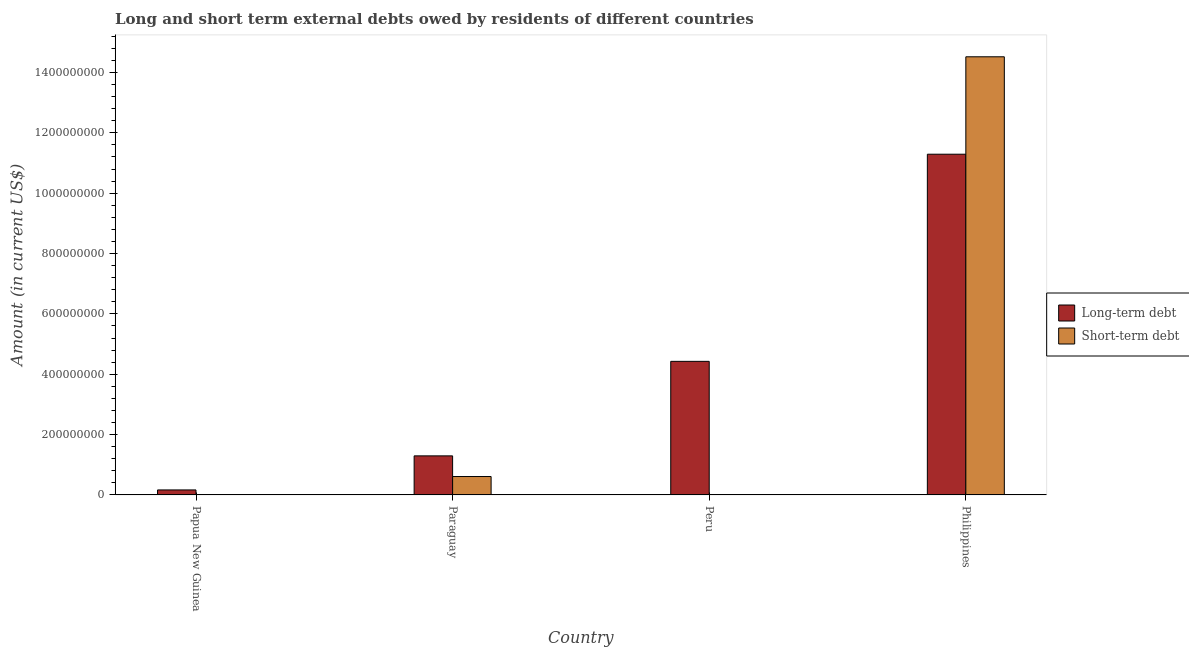Are the number of bars per tick equal to the number of legend labels?
Your answer should be compact. No. Are the number of bars on each tick of the X-axis equal?
Offer a very short reply. No. How many bars are there on the 4th tick from the left?
Your answer should be compact. 2. What is the label of the 3rd group of bars from the left?
Make the answer very short. Peru. What is the short-term debts owed by residents in Peru?
Give a very brief answer. 0. Across all countries, what is the maximum short-term debts owed by residents?
Offer a very short reply. 1.45e+09. Across all countries, what is the minimum long-term debts owed by residents?
Give a very brief answer. 1.66e+07. What is the total short-term debts owed by residents in the graph?
Provide a succinct answer. 1.51e+09. What is the difference between the long-term debts owed by residents in Papua New Guinea and that in Peru?
Your response must be concise. -4.26e+08. What is the difference between the long-term debts owed by residents in Peru and the short-term debts owed by residents in Papua New Guinea?
Provide a succinct answer. 4.43e+08. What is the average short-term debts owed by residents per country?
Provide a short and direct response. 3.78e+08. What is the difference between the long-term debts owed by residents and short-term debts owed by residents in Paraguay?
Your answer should be compact. 6.85e+07. In how many countries, is the long-term debts owed by residents greater than 40000000 US$?
Offer a very short reply. 3. What is the ratio of the long-term debts owed by residents in Peru to that in Philippines?
Offer a very short reply. 0.39. What is the difference between the highest and the second highest long-term debts owed by residents?
Your answer should be very brief. 6.86e+08. What is the difference between the highest and the lowest long-term debts owed by residents?
Make the answer very short. 1.11e+09. In how many countries, is the short-term debts owed by residents greater than the average short-term debts owed by residents taken over all countries?
Your answer should be very brief. 1. How many bars are there?
Ensure brevity in your answer.  6. Are all the bars in the graph horizontal?
Offer a very short reply. No. How many countries are there in the graph?
Provide a short and direct response. 4. Where does the legend appear in the graph?
Your answer should be compact. Center right. How are the legend labels stacked?
Your answer should be very brief. Vertical. What is the title of the graph?
Make the answer very short. Long and short term external debts owed by residents of different countries. What is the Amount (in current US$) of Long-term debt in Papua New Guinea?
Your answer should be compact. 1.66e+07. What is the Amount (in current US$) in Short-term debt in Papua New Guinea?
Provide a short and direct response. 0. What is the Amount (in current US$) of Long-term debt in Paraguay?
Give a very brief answer. 1.29e+08. What is the Amount (in current US$) in Short-term debt in Paraguay?
Keep it short and to the point. 6.10e+07. What is the Amount (in current US$) of Long-term debt in Peru?
Provide a succinct answer. 4.43e+08. What is the Amount (in current US$) of Short-term debt in Peru?
Your answer should be compact. 0. What is the Amount (in current US$) of Long-term debt in Philippines?
Offer a very short reply. 1.13e+09. What is the Amount (in current US$) of Short-term debt in Philippines?
Make the answer very short. 1.45e+09. Across all countries, what is the maximum Amount (in current US$) in Long-term debt?
Your answer should be very brief. 1.13e+09. Across all countries, what is the maximum Amount (in current US$) of Short-term debt?
Your response must be concise. 1.45e+09. Across all countries, what is the minimum Amount (in current US$) in Long-term debt?
Make the answer very short. 1.66e+07. What is the total Amount (in current US$) in Long-term debt in the graph?
Your answer should be very brief. 1.72e+09. What is the total Amount (in current US$) of Short-term debt in the graph?
Give a very brief answer. 1.51e+09. What is the difference between the Amount (in current US$) in Long-term debt in Papua New Guinea and that in Paraguay?
Keep it short and to the point. -1.13e+08. What is the difference between the Amount (in current US$) of Long-term debt in Papua New Guinea and that in Peru?
Keep it short and to the point. -4.26e+08. What is the difference between the Amount (in current US$) in Long-term debt in Papua New Guinea and that in Philippines?
Give a very brief answer. -1.11e+09. What is the difference between the Amount (in current US$) of Long-term debt in Paraguay and that in Peru?
Ensure brevity in your answer.  -3.13e+08. What is the difference between the Amount (in current US$) of Long-term debt in Paraguay and that in Philippines?
Give a very brief answer. -1.00e+09. What is the difference between the Amount (in current US$) in Short-term debt in Paraguay and that in Philippines?
Provide a succinct answer. -1.39e+09. What is the difference between the Amount (in current US$) of Long-term debt in Peru and that in Philippines?
Your response must be concise. -6.86e+08. What is the difference between the Amount (in current US$) of Long-term debt in Papua New Guinea and the Amount (in current US$) of Short-term debt in Paraguay?
Offer a terse response. -4.44e+07. What is the difference between the Amount (in current US$) of Long-term debt in Papua New Guinea and the Amount (in current US$) of Short-term debt in Philippines?
Provide a short and direct response. -1.44e+09. What is the difference between the Amount (in current US$) in Long-term debt in Paraguay and the Amount (in current US$) in Short-term debt in Philippines?
Your response must be concise. -1.32e+09. What is the difference between the Amount (in current US$) of Long-term debt in Peru and the Amount (in current US$) of Short-term debt in Philippines?
Offer a terse response. -1.01e+09. What is the average Amount (in current US$) in Long-term debt per country?
Offer a terse response. 4.29e+08. What is the average Amount (in current US$) of Short-term debt per country?
Your response must be concise. 3.78e+08. What is the difference between the Amount (in current US$) in Long-term debt and Amount (in current US$) in Short-term debt in Paraguay?
Offer a very short reply. 6.85e+07. What is the difference between the Amount (in current US$) of Long-term debt and Amount (in current US$) of Short-term debt in Philippines?
Make the answer very short. -3.23e+08. What is the ratio of the Amount (in current US$) in Long-term debt in Papua New Guinea to that in Paraguay?
Provide a succinct answer. 0.13. What is the ratio of the Amount (in current US$) of Long-term debt in Papua New Guinea to that in Peru?
Offer a very short reply. 0.04. What is the ratio of the Amount (in current US$) in Long-term debt in Papua New Guinea to that in Philippines?
Offer a very short reply. 0.01. What is the ratio of the Amount (in current US$) of Long-term debt in Paraguay to that in Peru?
Ensure brevity in your answer.  0.29. What is the ratio of the Amount (in current US$) of Long-term debt in Paraguay to that in Philippines?
Make the answer very short. 0.11. What is the ratio of the Amount (in current US$) of Short-term debt in Paraguay to that in Philippines?
Provide a succinct answer. 0.04. What is the ratio of the Amount (in current US$) of Long-term debt in Peru to that in Philippines?
Provide a short and direct response. 0.39. What is the difference between the highest and the second highest Amount (in current US$) in Long-term debt?
Your response must be concise. 6.86e+08. What is the difference between the highest and the lowest Amount (in current US$) of Long-term debt?
Give a very brief answer. 1.11e+09. What is the difference between the highest and the lowest Amount (in current US$) in Short-term debt?
Make the answer very short. 1.45e+09. 